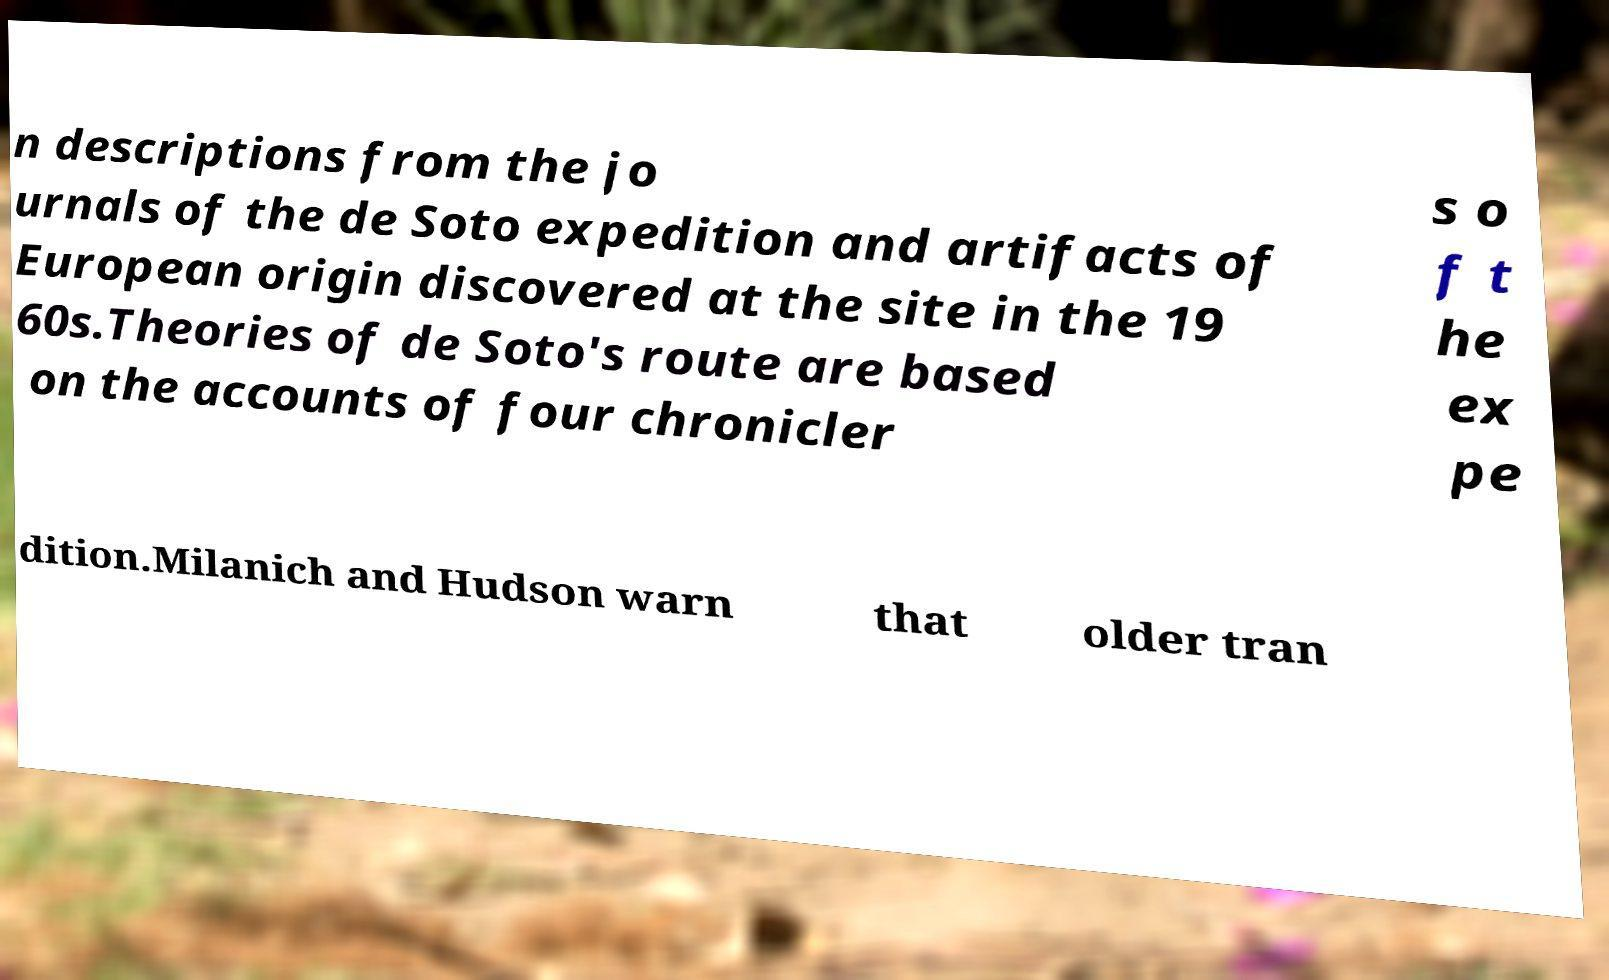I need the written content from this picture converted into text. Can you do that? n descriptions from the jo urnals of the de Soto expedition and artifacts of European origin discovered at the site in the 19 60s.Theories of de Soto's route are based on the accounts of four chronicler s o f t he ex pe dition.Milanich and Hudson warn that older tran 